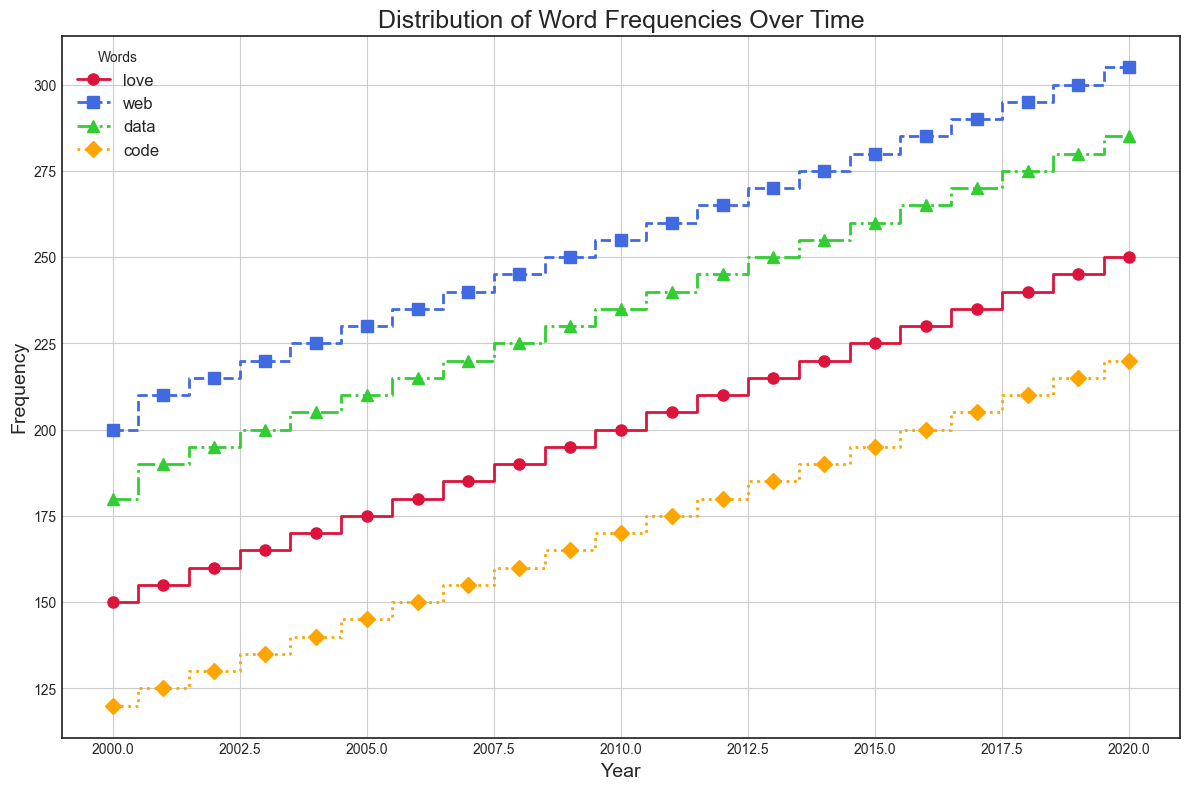What is the trend in the frequency of the word "web" from 2000 to 2020? Observe the blue line (representing "web") on the plot. The line steadily increases from 2000 to 2020, indicating a continuous rise in frequency.
Answer: Steadily increasing Which word experienced the highest increase in frequency from 2000 to 2020? Analyze the slopes of all lines from 2000 to 2020. The word "web," shown in blue, has the steepest overall increase.
Answer: web Between the words "data" and "code," which one had a higher frequency in 2010? Locate the points for "data" (green) and "code" (orange) for the year 2010. The point for "data" is higher on the graph than the point for "code."
Answer: data What was the average frequency of the word "love" over the years presented? Sum the frequencies of "love" from each year and divide by the total number of years (250+245+...+150)/21. Calculations: (250+245+240+235+230+225+220+215+210+205+200+195+190+185+180+175+170+165+160+155+150)/21 = 200
Answer: 200 Which year saw the highest frequency for the word "data"? Locate the green line representing "data" and identify the highest point, which occurs in 2020.
Answer: 2020 Compare the frequency of the word "code" in 2005 and 2015. Which year had a higher frequency? Locate the points for "code" (orange) in 2005 and 2015. The point in 2015 is higher than in 2005.
Answer: 2015 What is the difference in frequency between "love" and "web" in the year 2000? Locate the points for "love" (red) and "web" (blue) in the year 2000. Subtract the frequency of "love" from "web": 200 - 150 = 50.
Answer: 50 Among the words "love," "web," "data," and "code," which had the lowest frequency in 2004? Locate the points for all four words in 2004. The point for "code" (orange) is the lowest.
Answer: code What is the combined frequency of "data" and "code" in 2019? Add the frequencies of "data" (280) and "code" (215) for 2019: 280 + 215 = 495.
Answer: 495 How many times did the frequency of "love" equal 200? Check the red line (representing "love") for points equal to 200. This occurs once, in the year 2010.
Answer: once 